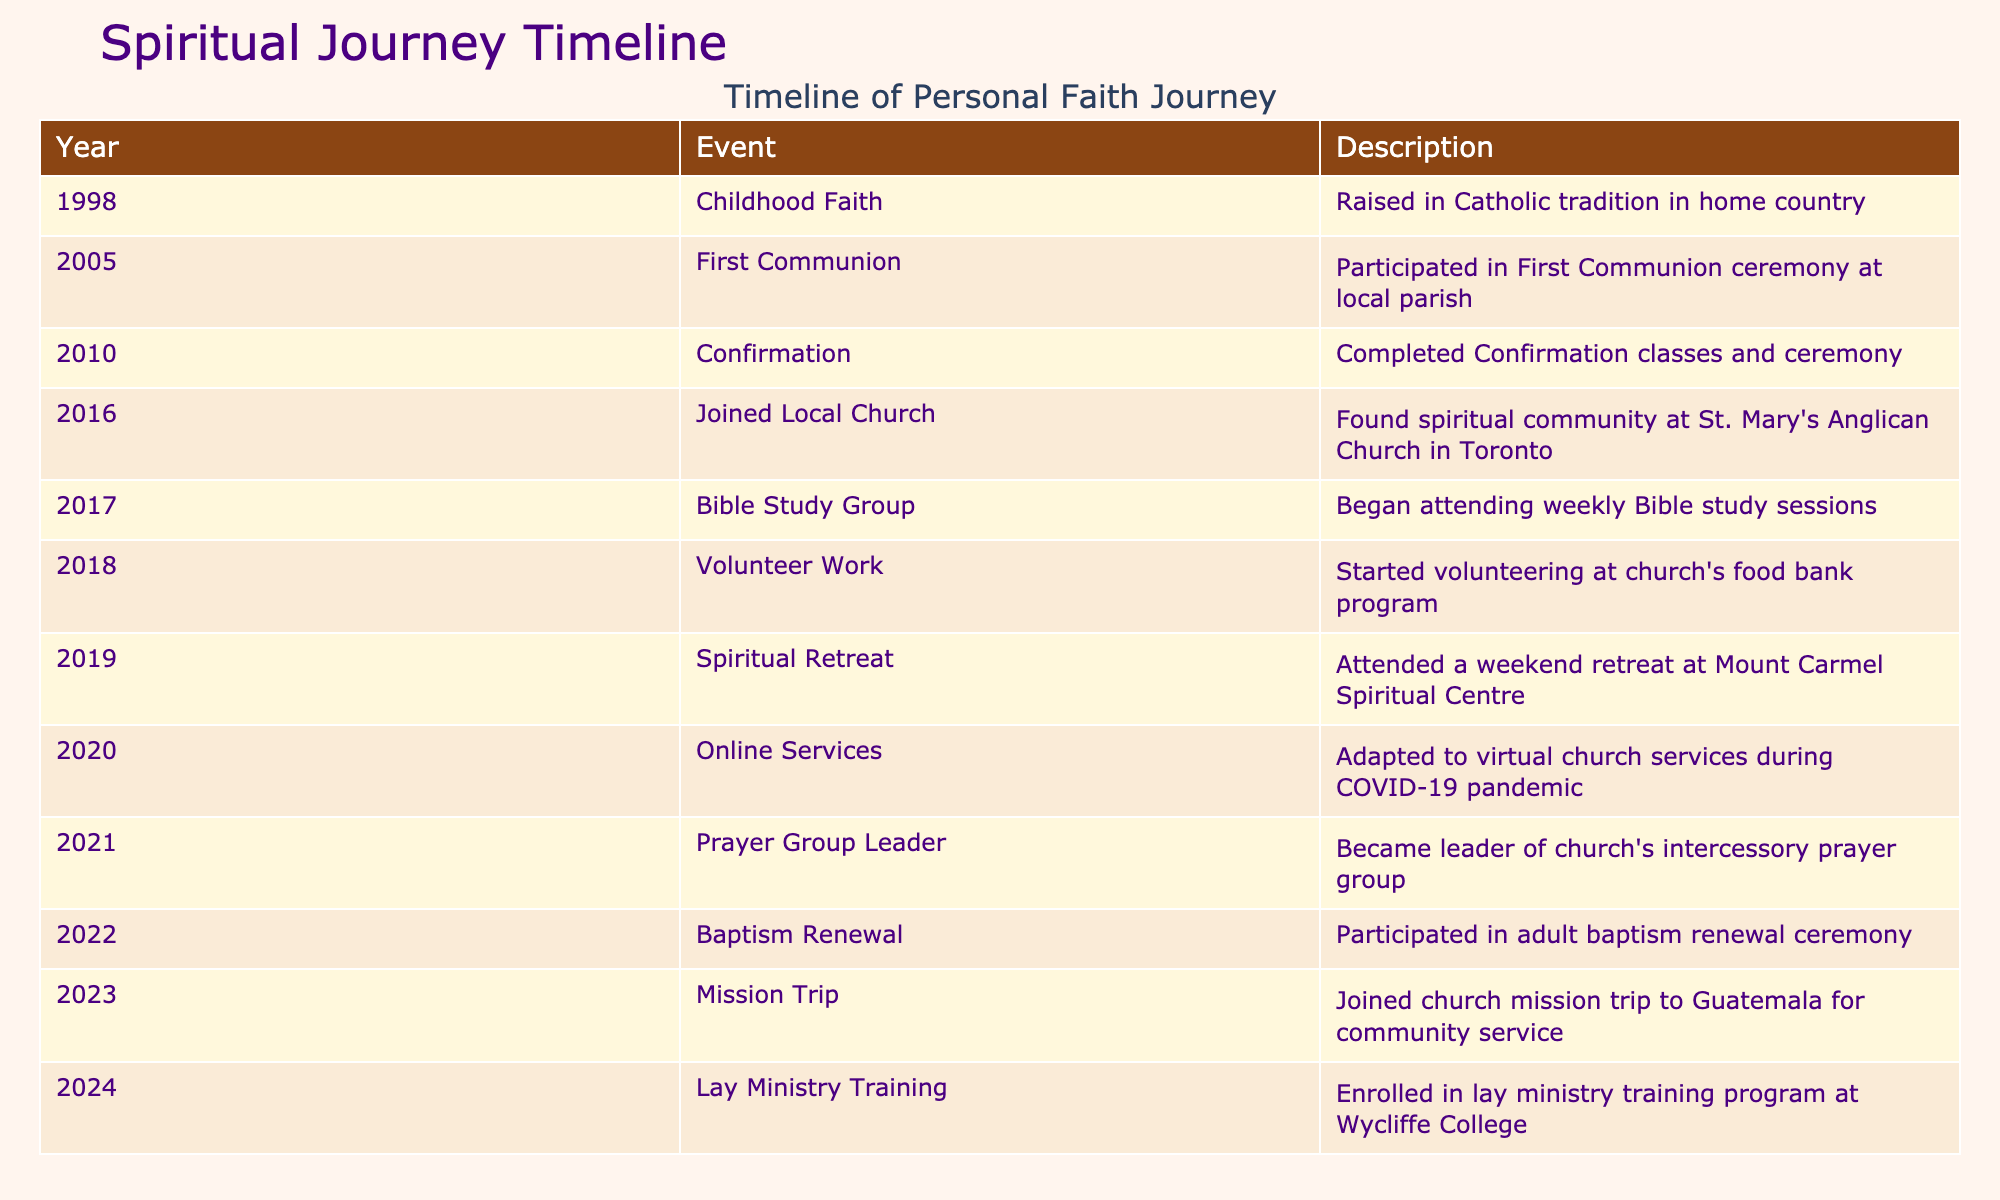What year did you participate in First Communion? The table lists the event "First Communion" in the year column under 2005. Therefore, the answer is directly found in the table for that specific event.
Answer: 2005 How many significant spiritual events occurred between 2015 and 2020? The events between 2015 and 2020 include: "Joined Local Church" (2016), "Bible Study Group" (2017), "Volunteer Work" (2018), "Spiritual Retreat" (2019), and "Online Services" (2020). Adding these up gives a total of 5 events.
Answer: 5 Was there a significant spiritual event in the year 2022? The table lists "Baptism Renewal" as an event in the year 2022. This is a yes or no question that can be answered by checking if there is any entry for that year in the data.
Answer: Yes In how many years did you take part in volunteering activities? The volunteering activity began in 2018 with "Volunteer Work" and continued with "Mission Trip" in 2023, making it 2 distinct years of participation. Therefore, we count these years from the events listed.
Answer: 2 What is the time span between your first significant faith event and the latest event in the table? The first significant event listed is "Childhood Faith" in 1998 and the latest event is "Lay Ministry Training" in 2024. Thus, performing a simple subtraction: 2024 - 1998 = 26 years shows the time span.
Answer: 26 years Which event took place immediately after joining the local church in 2016? The event that followed "Joined Local Church" in 2016 is "Bible Study Group" in 2017. We can determine this by looking at the chronological order of the events listed.
Answer: Bible Study Group What year did you become the leader of the church's intercessory prayer group? The table indicates that the event "Prayer Group Leader" occurred in 2021, providing a specific year for that role. This information can be directly retrieved from the table.
Answer: 2021 How many events occurred after the online services began in 2020? The events listed after "Online Services" (2020) are: "Prayer Group Leader" (2021), "Baptism Renewal" (2022), "Mission Trip" (2023), and "Lay Ministry Training" (2024). By counting these entries, we find there are 4 events.
Answer: 4 What significant growth in your spiritual journey can be observed from 2010 to 2024? Examining the events from 2010 (Confirmation) to 2024 (Lay Ministry Training), we can see a progression that includes further engagement in the community through various roles such as volunteering and training, indicating deepening involvement. This involves assessing the nature of each event and how it contributes to spiritual growth.
Answer: Increased community involvement and deeper commitments 